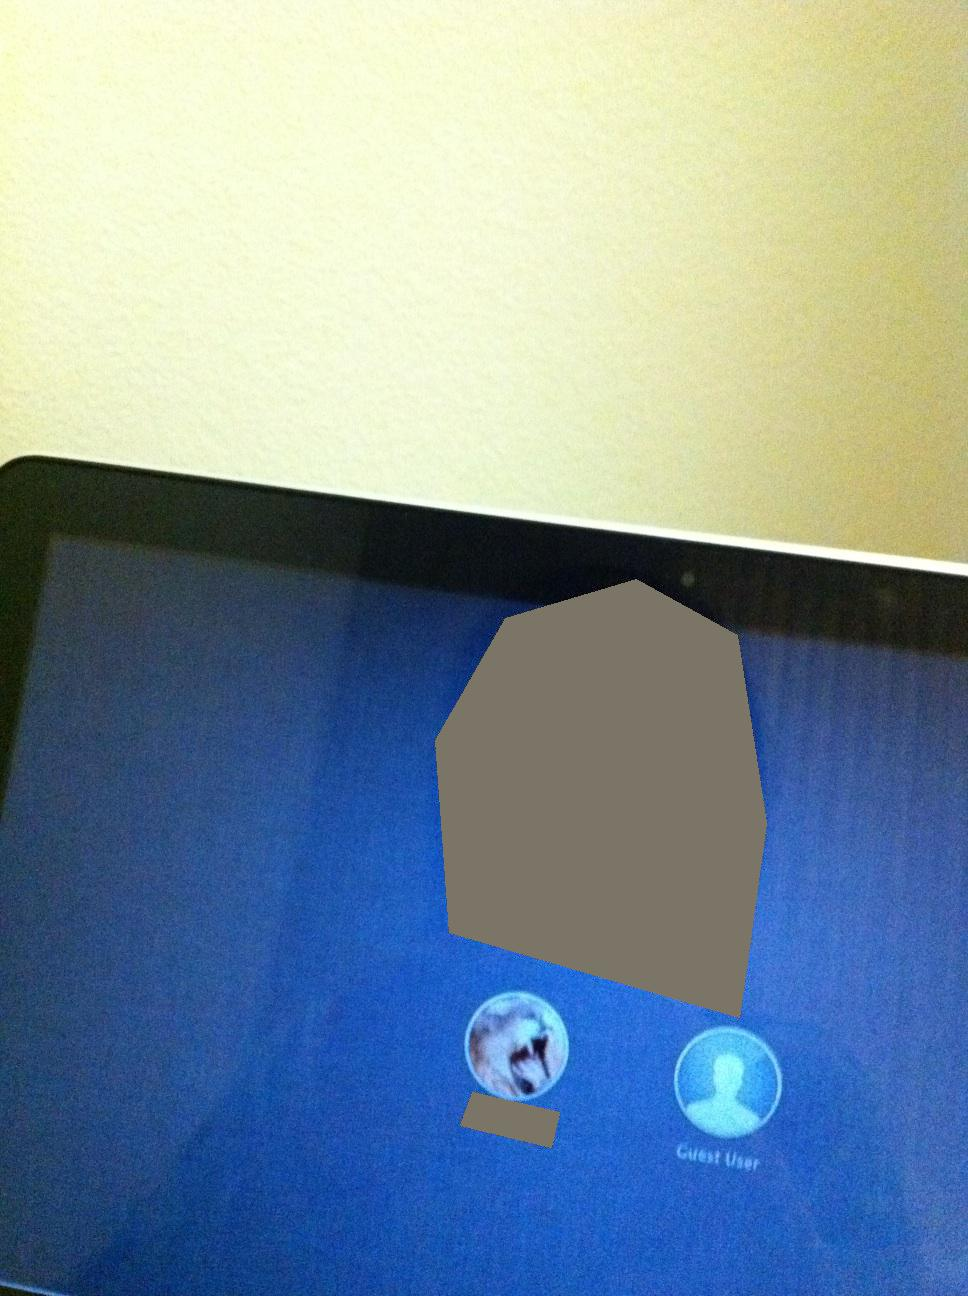If you could transform the image into an interactive virtual reality experience, what unique features or elements would you add to make it engaging? Transforming this image into a virtual reality experience, I would add interactive elements such as hovering tooltips explaining each user option, voice-activated commands to select users, and a dynamic background that changes based on user input. There could also be a feature where choosing a user immerses you in a virtual space representing their personalized desktop environment. 